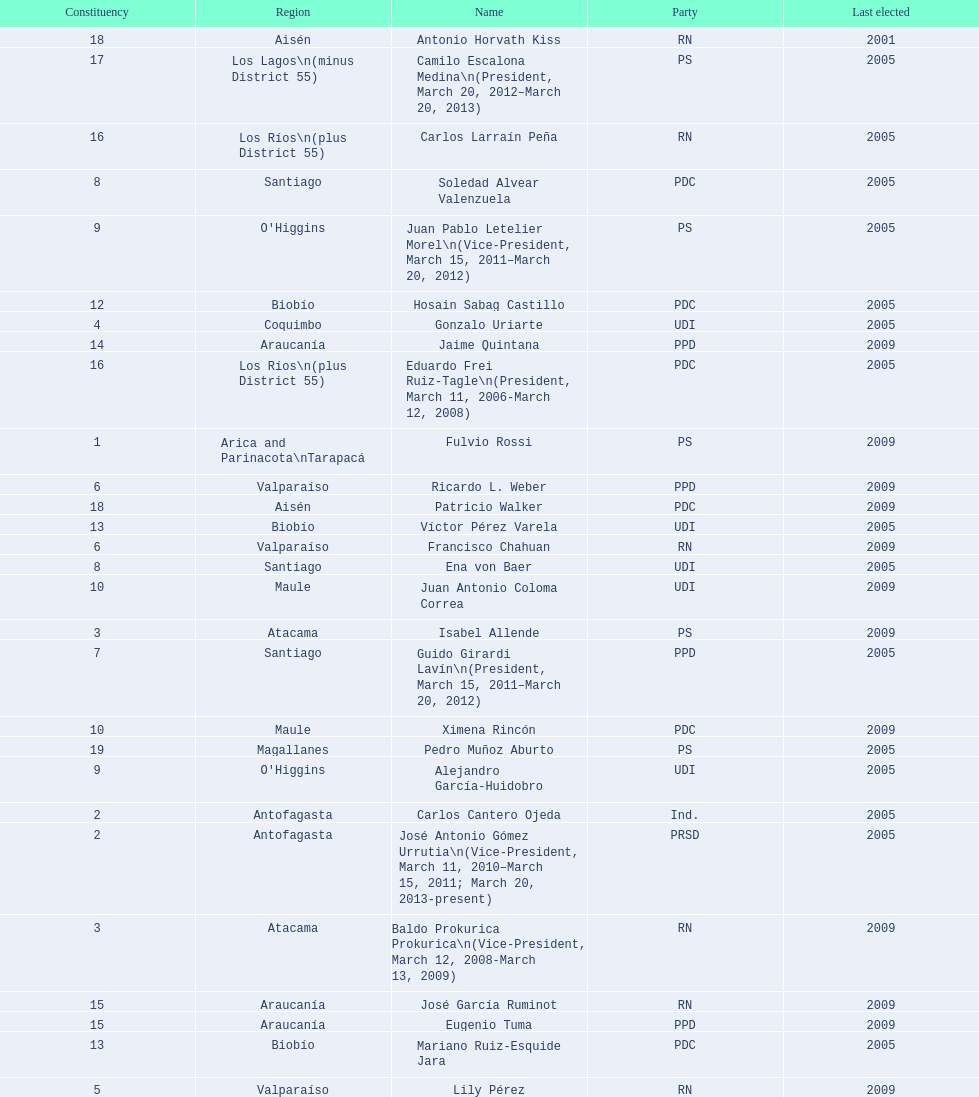How long was baldo prokurica prokurica vice-president? 1 year. 